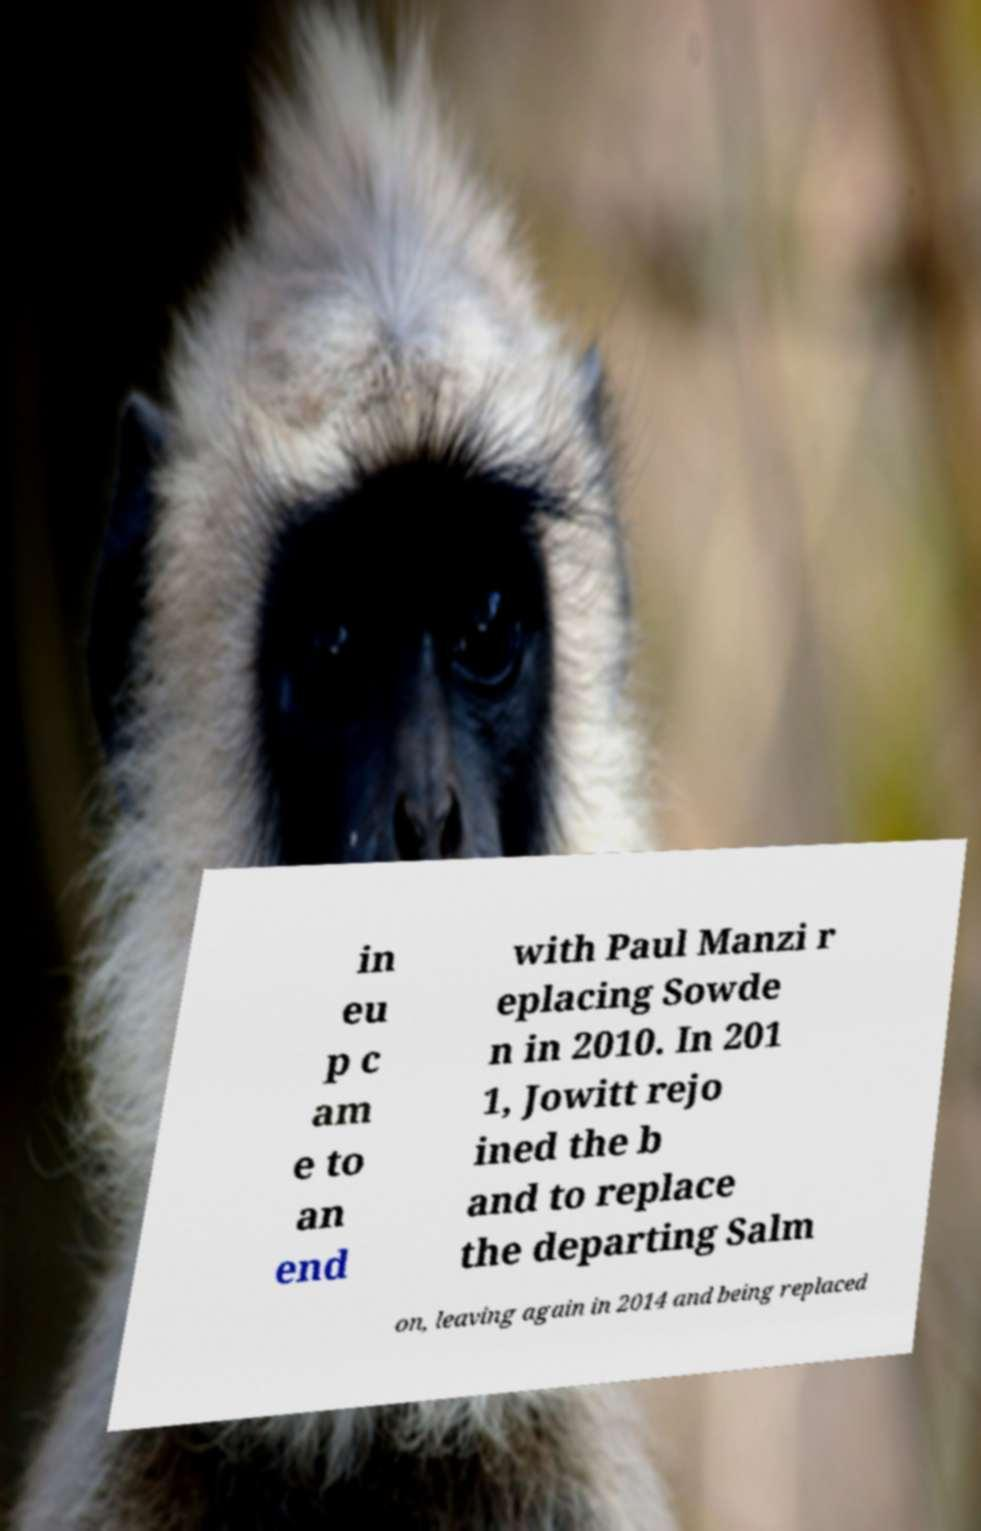I need the written content from this picture converted into text. Can you do that? in eu p c am e to an end with Paul Manzi r eplacing Sowde n in 2010. In 201 1, Jowitt rejo ined the b and to replace the departing Salm on, leaving again in 2014 and being replaced 